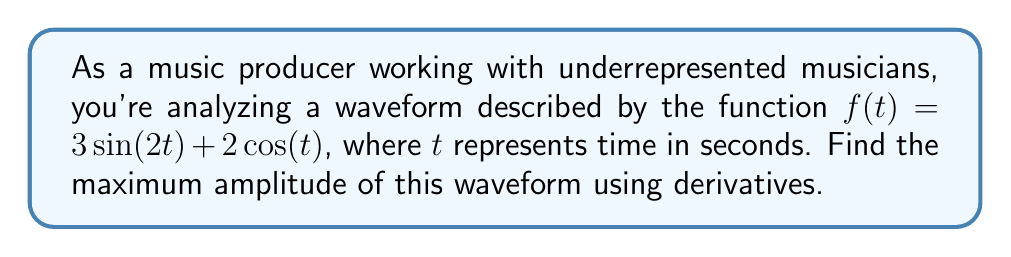Solve this math problem. 1) To find the maximum amplitude, we need to find the maximum absolute value of the function. This occurs at the local extrema of the function.

2) To find the local extrema, we need to find where the derivative of the function equals zero.

3) Let's find the derivative of $f(t)$:
   $$f'(t) = 3 \cdot 2\cos(2t) + 2 \cdot (-\sin(t)) = 6\cos(2t) - 2\sin(t)$$

4) Set the derivative equal to zero:
   $$6\cos(2t) - 2\sin(t) = 0$$

5) This equation is complex to solve analytically. In practice, we would use numerical methods to find the solutions.

6) However, we can find the maximum amplitude without solving for $t$. The maximum amplitude will be the square root of the sum of the squares of the coefficients of the sine and cosine terms in the original function.

7) In this case:
   $$\text{Maximum Amplitude} = \sqrt{3^2 + 2^2} = \sqrt{9 + 4} = \sqrt{13}$$

8) This method works because $\sin(2t)$ and $\cos(t)$ are orthogonal functions, and their maximum values are 1 and -1.
Answer: $\sqrt{13}$ 